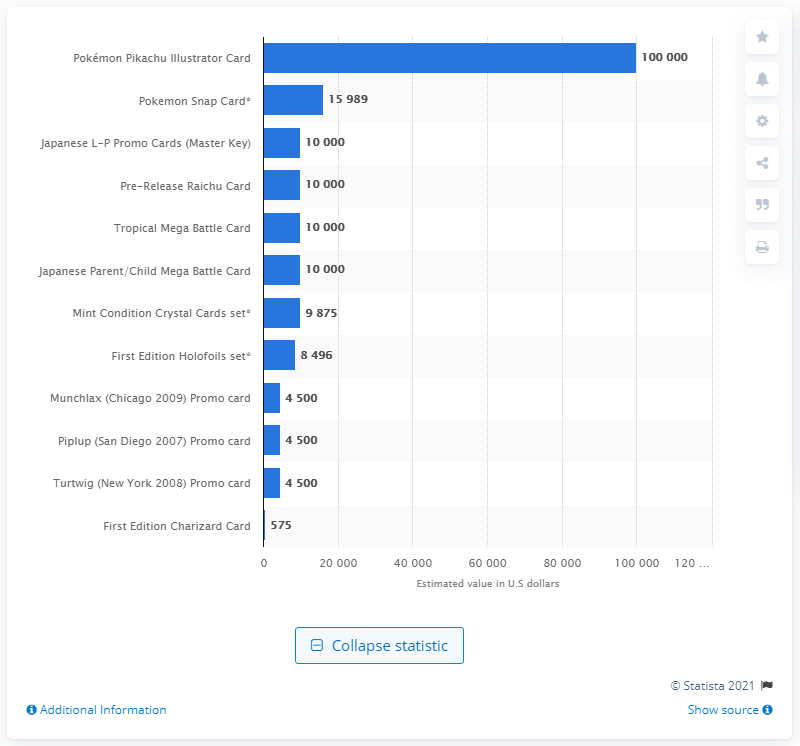Give some essential details in this illustration. As of 2016, the value of a Pokémon Pikachu Illustrator card was 100,000. 